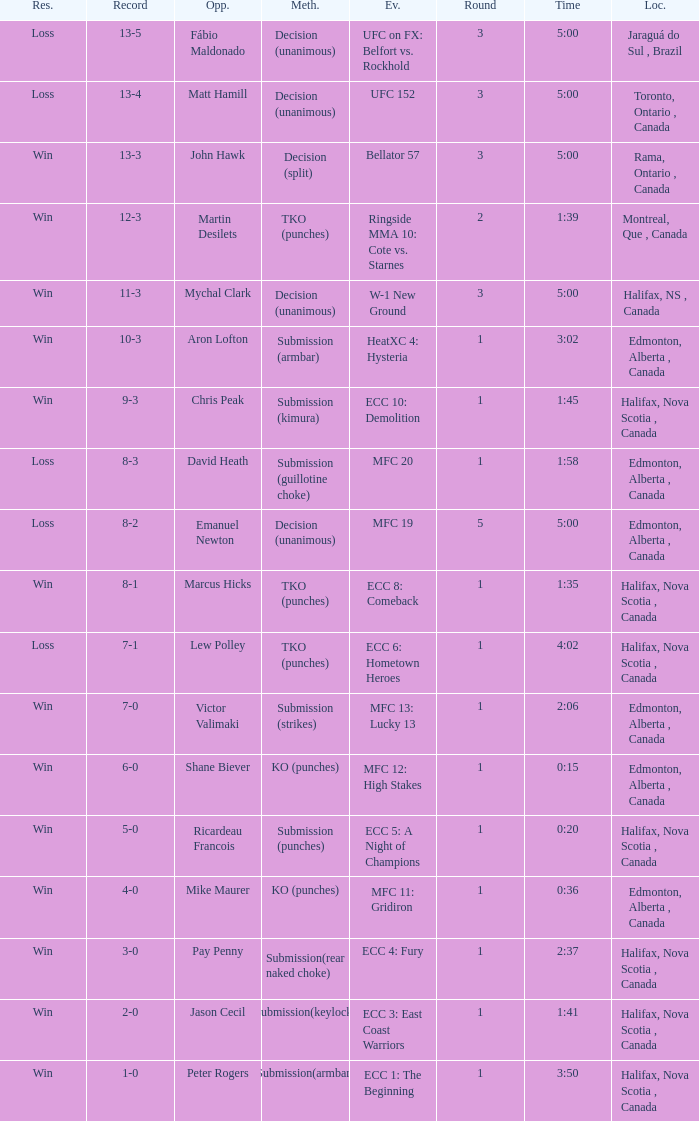What is the location of the match with Aron Lofton as the opponent? Edmonton, Alberta , Canada. 